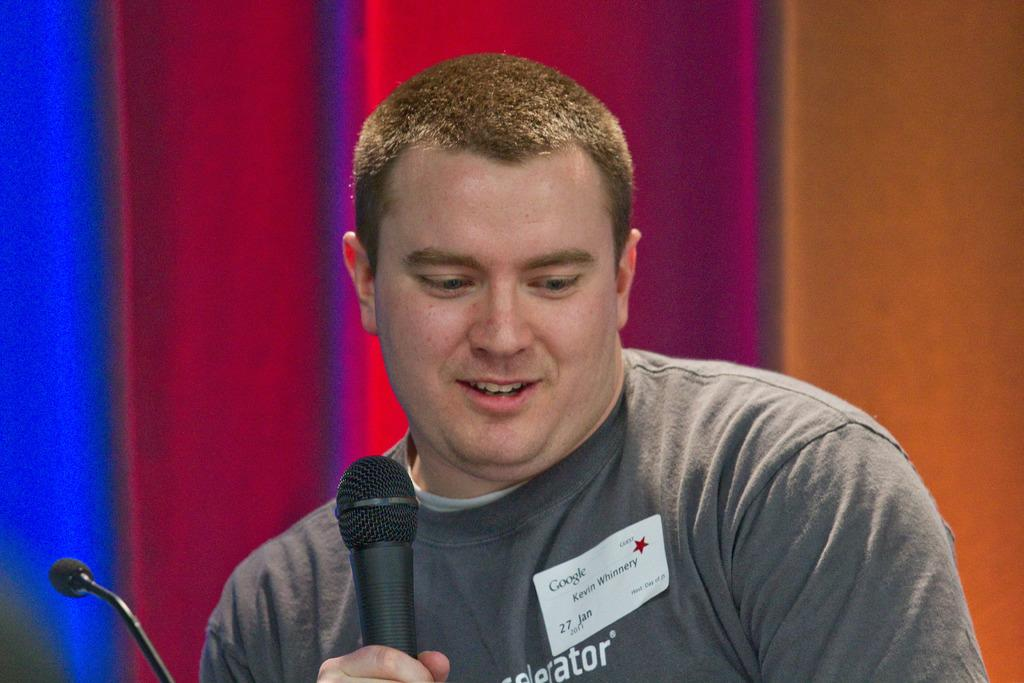What is the man in the image holding? The man is holding a microphone. Are there any other microphones visible in the image? Yes, there is another microphone beside the man. What can be seen on the man's shirt? The man has a sticker on his shirt. What is visible in the background of the image? There is a wall in the background of the image. What type of animals can be seen in the zoo in the image? There is no zoo present in the image; it features a man holding a microphone and another microphone beside him. 